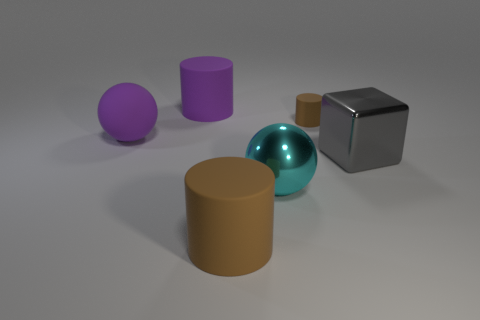Add 3 big purple spheres. How many objects exist? 9 Subtract all spheres. How many objects are left? 4 Add 6 small cylinders. How many small cylinders are left? 7 Add 5 big brown shiny balls. How many big brown shiny balls exist? 5 Subtract 0 blue cylinders. How many objects are left? 6 Subtract all purple matte spheres. Subtract all large brown rubber objects. How many objects are left? 4 